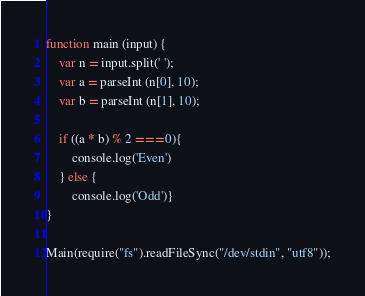<code> <loc_0><loc_0><loc_500><loc_500><_JavaScript_>function main (input) {
	var n = input.split(' ');
  	var a = parseInt (n[0], 10);
  	var b = parseInt (n[1], 10);
  
  	if ((a * b) % 2 === 0){
      	console.log('Even')
    } else {
      	console.log('Odd')}
}

Main(require("fs").readFileSync("/dev/stdin", "utf8"));
</code> 